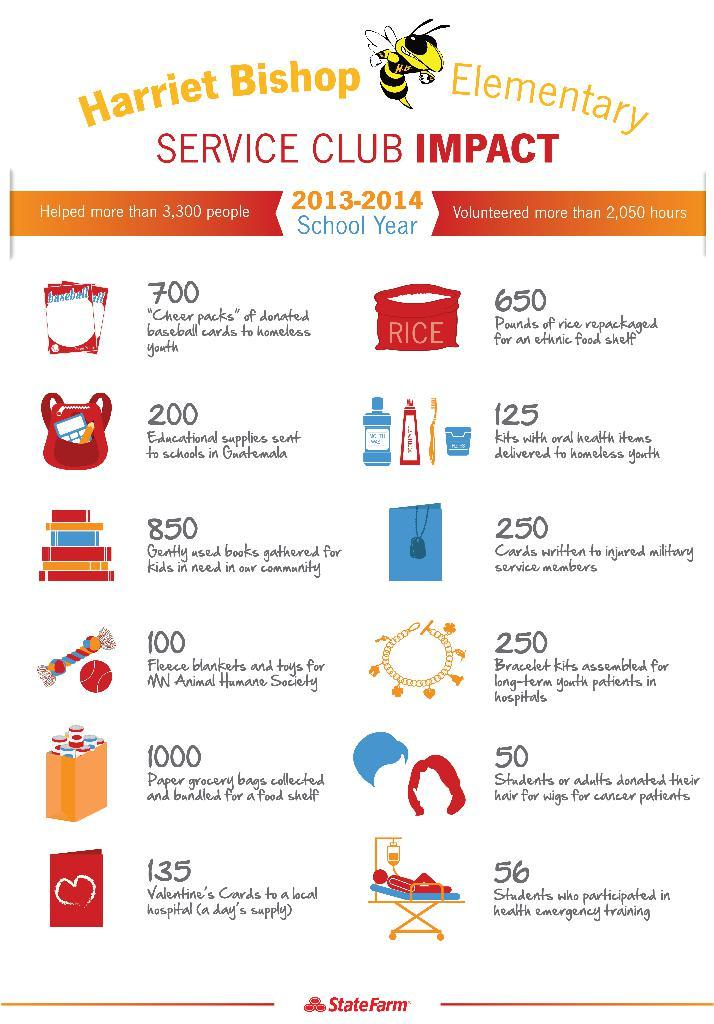What is featured on the poster in the image? The poster in the image displays different products. Can you describe the information provided on the poster? The poster shows the prices of the products. What type of creature can be seen exploring space in the image? There is no creature or space exploration depicted in the image; it features a poster displaying products and their prices. 